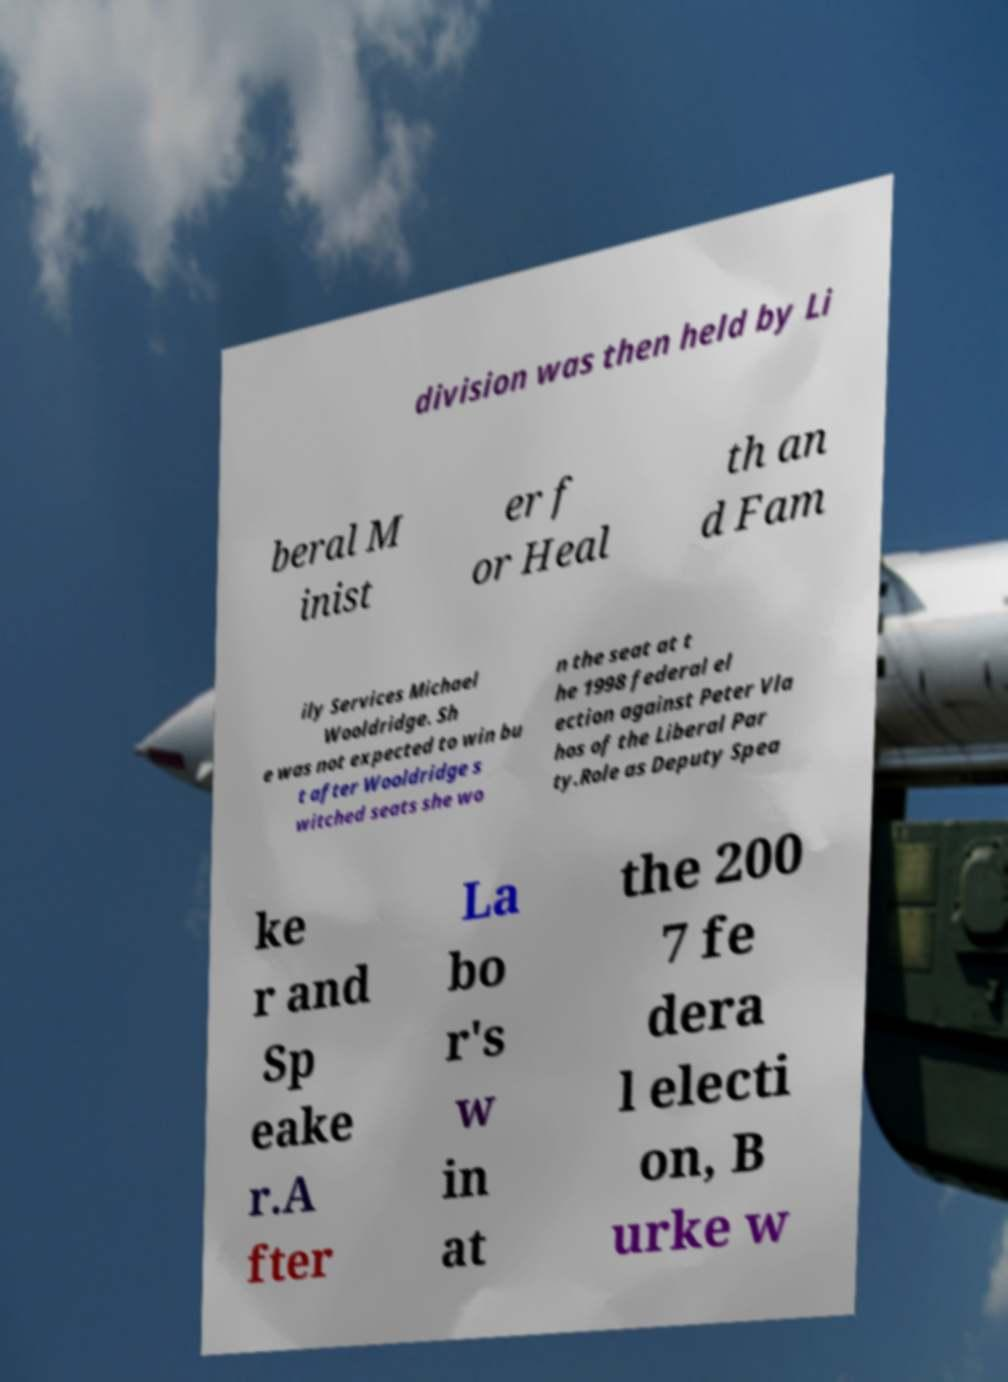Please identify and transcribe the text found in this image. division was then held by Li beral M inist er f or Heal th an d Fam ily Services Michael Wooldridge. Sh e was not expected to win bu t after Wooldridge s witched seats she wo n the seat at t he 1998 federal el ection against Peter Vla hos of the Liberal Par ty.Role as Deputy Spea ke r and Sp eake r.A fter La bo r's w in at the 200 7 fe dera l electi on, B urke w 